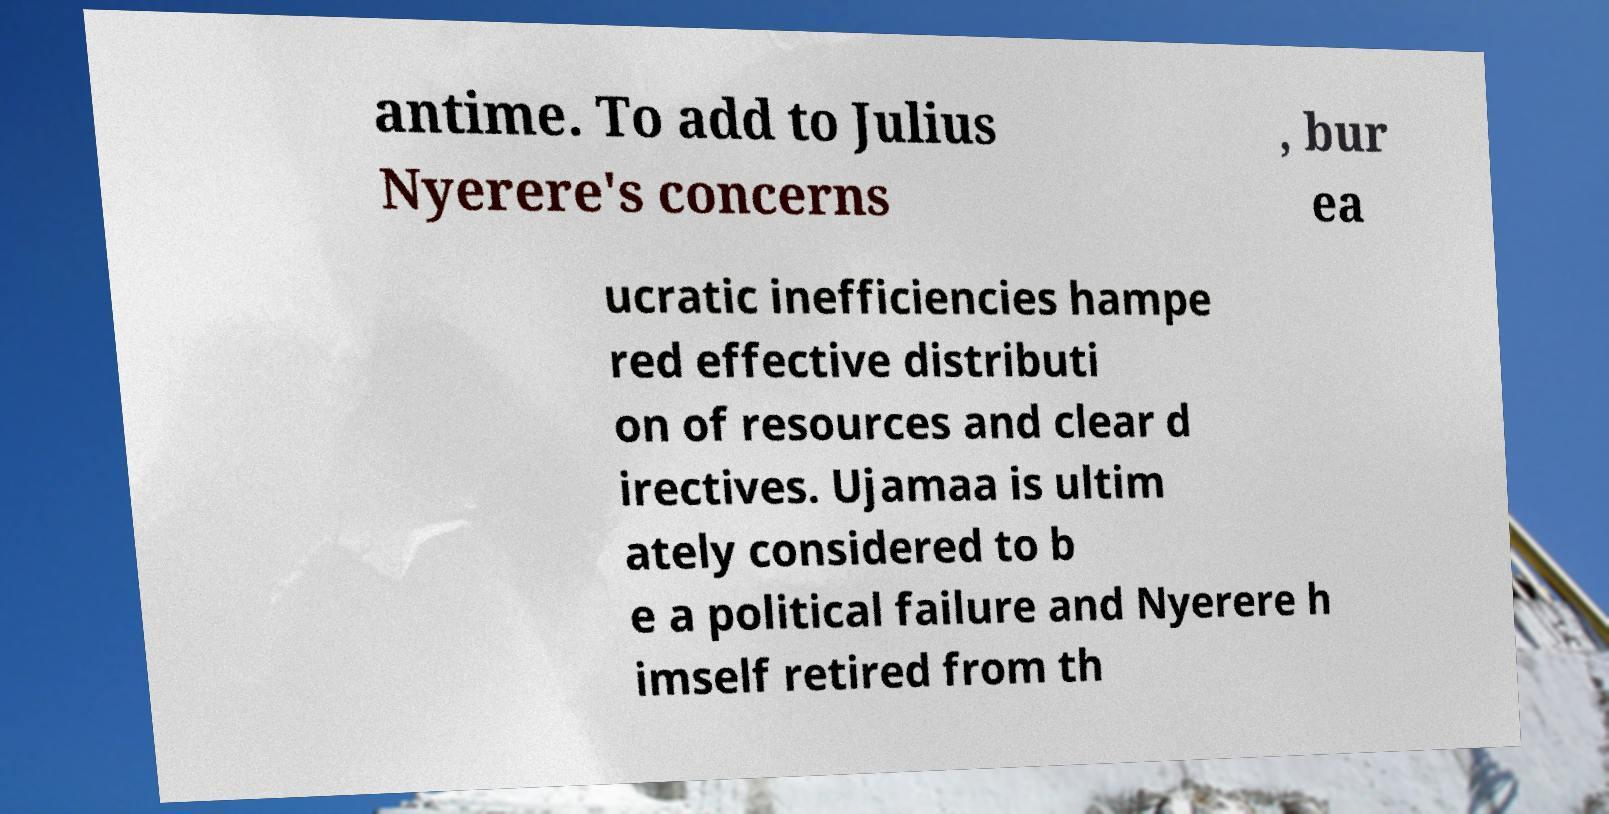Please identify and transcribe the text found in this image. antime. To add to Julius Nyerere's concerns , bur ea ucratic inefficiencies hampe red effective distributi on of resources and clear d irectives. Ujamaa is ultim ately considered to b e a political failure and Nyerere h imself retired from th 